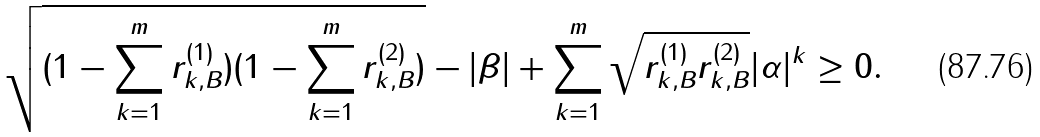<formula> <loc_0><loc_0><loc_500><loc_500>\sqrt { ( 1 - \sum _ { k = 1 } ^ { m } r _ { k , B } ^ { ( 1 ) } ) ( 1 - \sum _ { k = 1 } ^ { m } r _ { k , B } ^ { ( 2 ) } ) } - | \beta | + \sum _ { k = 1 } ^ { m } \sqrt { r _ { k , B } ^ { ( 1 ) } r _ { k , B } ^ { ( 2 ) } } | \alpha | ^ { k } \geq 0 .</formula> 